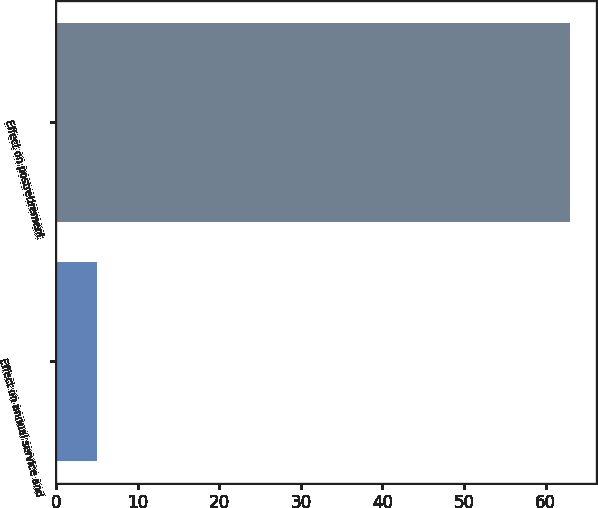Convert chart to OTSL. <chart><loc_0><loc_0><loc_500><loc_500><bar_chart><fcel>Effect on annual service and<fcel>Effect on postretirement<nl><fcel>5<fcel>63<nl></chart> 